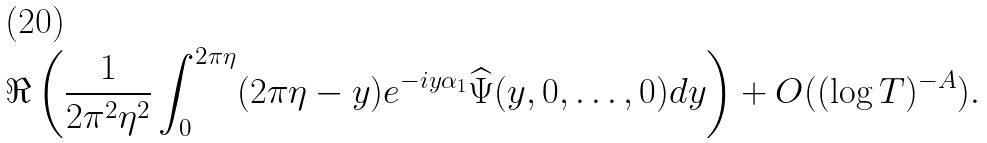Convert formula to latex. <formula><loc_0><loc_0><loc_500><loc_500>\Re \left ( \frac { 1 } { 2 \pi ^ { 2 } \eta ^ { 2 } } \int _ { 0 } ^ { 2 \pi \eta } ( 2 \pi \eta - y ) e ^ { - i y \alpha _ { 1 } } \widehat { \Psi } ( y , 0 , \dots , 0 ) d y \right ) + O ( ( \log T ) ^ { - A } ) .</formula> 